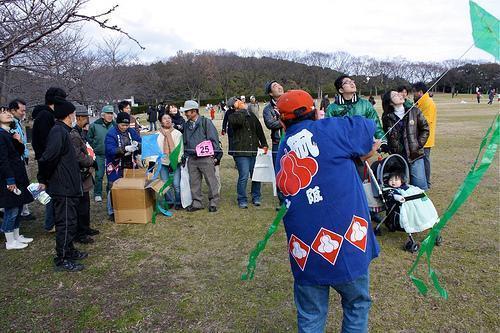How many people are there?
Give a very brief answer. 6. How many reflections of a cat are visible?
Give a very brief answer. 0. 